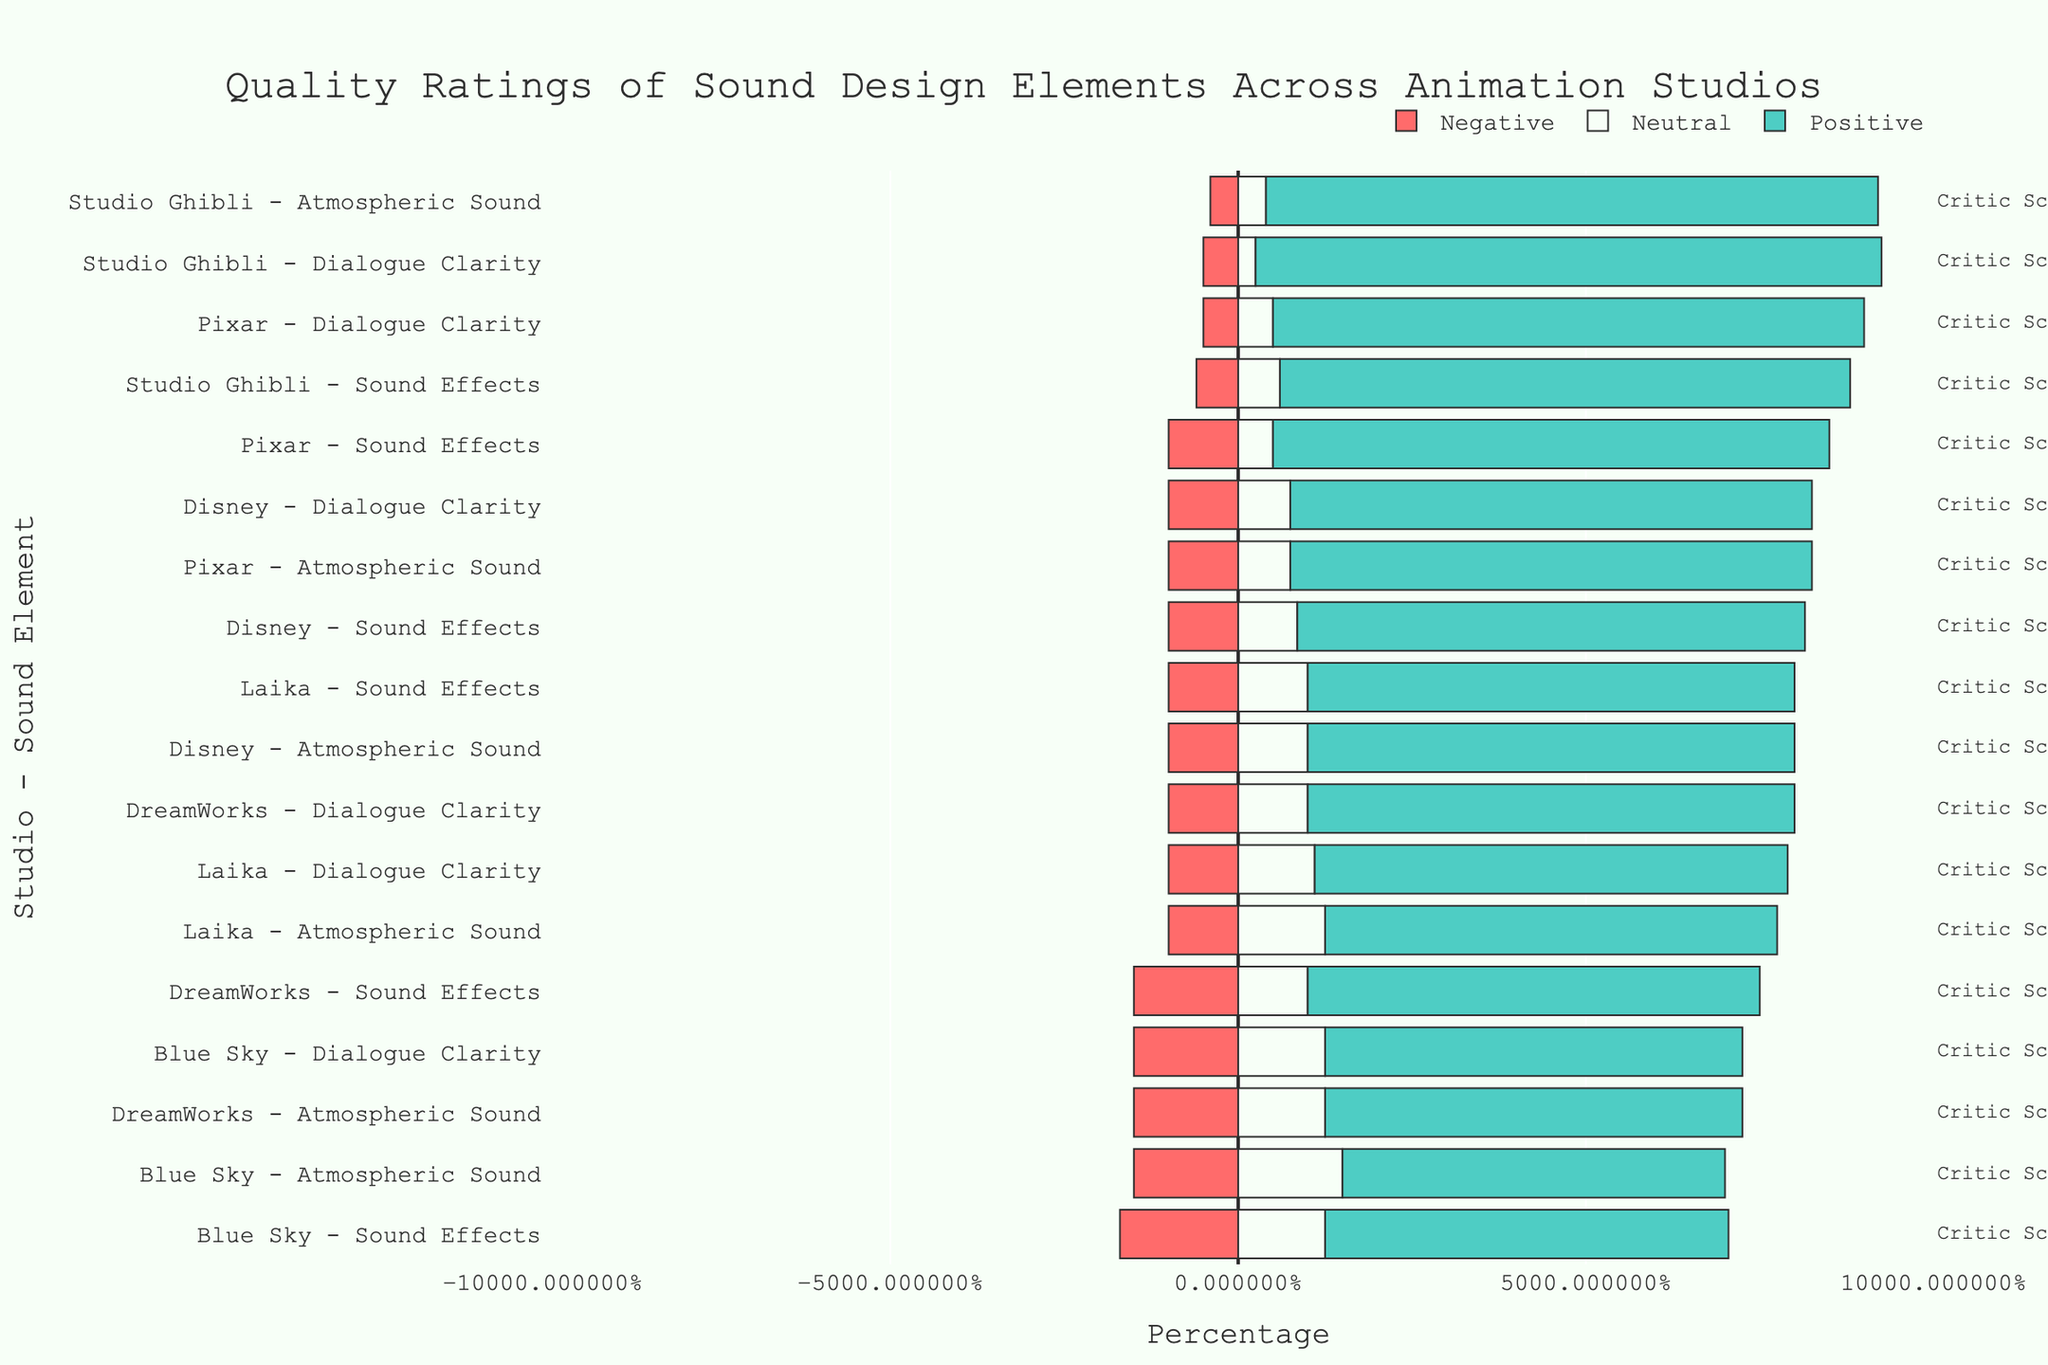What percentage of Pixar's sound design elements are rated positively? We need to find the average of the positive ratings for Pixar’s sound design elements. The positive ratings are 85 (Dialogue Clarity), 75 (Atmospheric Sound), and 80 (Sound Effects). Thus, (85 + 75 + 80) / 3 = 80.
Answer: 80% Which studio has the highest negative rating for Dialogue Clarity? Looking at the Dialogue Clarity bars colored in red for the studios, Blue Sky has the highest negative rating at 15%.
Answer: Blue Sky Compare the neutral ratings for Atmospheric Sound between DreamWorks and Disney. DreamWorks has a neutral rating of 25% for Atmospheric Sound, while Disney has a neutral rating of 20%. DreamWorks has a higher neutral rating than Disney.
Answer: DreamWorks Which studio and sound element combination has the lowest positive rating? The positive ratings need to be checked for each studio and sound element combination. Blue Sky's Atmospheric Sound has the lowest positive rating at 55%.
Answer: Blue Sky – Atmospheric Sound Among Pixar, DreamWorks, and Studio Ghibli, which has the highest average critic score, and what is it? The critic scores for Pixar are 92, 88, and 90. For DreamWorks, they are 85, 80, and 83. For Studio Ghibli, they are 95, 94, and 91. The average for Pixar is (92 + 88 + 90) / 3 = 90. The average for DreamWorks is (85 + 80 + 83) / 3 = 82.67. The average for Studio Ghibli is (95 + 94 + 91) / 3 = 93.33. Studio Ghibli has the highest average critic score of 93.33.
Answer: Studio Ghibli, 93.33 What is the difference in positive ratings for Sound Effects between Studio Ghibli and Laika? Studio Ghibli's positive rating for Sound Effects is 82%, and Laika's is 70%. The difference is 82 - 70 = 12.
Answer: 12 Which sound element for Disney has the least variation in its ratings (positive, neutral, and negative)? Disney's Dialogue Clarity has positive 75%, neutral 15%, negative 10%; Atmospheric Sound has positive 70%, neutral 20%, negative 10%; Sound Effects has positive 73%, neutral 17%, negative 10%. Dialogue Clarity has 75 - 10 = 65 variation, Atmospheric Sound has 70 - 10 = 60 variation, and Sound Effects has 73 - 10 = 63 variation. Atmospheric Sound has the least variation.
Answer: Atmospheric Sound Rank the studios in descending order of their positive ratings for Dialogue Clarity. Studio Ghibli has the highest positive rating at 90%, followed by Pixar at 85%, Disney at 75%, DreamWorks at 70%, Laika at 68%, and Blue Sky at 60%.
Answer: Studio Ghibli, Pixar, Disney, DreamWorks, Laika, Blue Sky What is the average neutral rating for all studios across all sound elements? We sum all neutral ratings and divide by the number of entries. The sum of neutral ratings (10+15+10+20+25+20+5+8+12+15+20+17+22+25+20+25+30+25) is 336, and there are 18 entries. So the average is 336/18 = 18.67.
Answer: 18.67 Between Sound Effects of Pixar and Dialogue Clarity of DreamWorks, which has a higher positive rating? The positive rating for Pixar's Sound Effects is 80%, and for DreamWorks' Dialogue Clarity, it's 70%. Pixar's Sound Effects have a higher positive rating.
Answer: Pixar's Sound Effects 